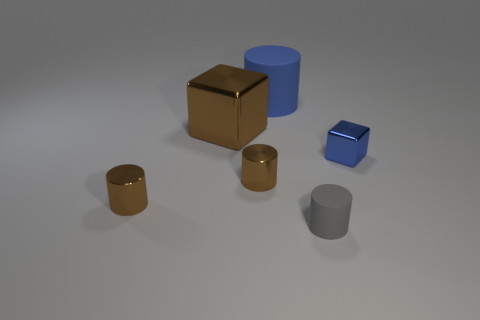Add 4 small gray matte cylinders. How many objects exist? 10 Subtract all cubes. How many objects are left? 4 Add 5 small shiny things. How many small shiny things exist? 8 Subtract 0 gray cubes. How many objects are left? 6 Subtract all cubes. Subtract all tiny blue metal blocks. How many objects are left? 3 Add 4 brown shiny cylinders. How many brown shiny cylinders are left? 6 